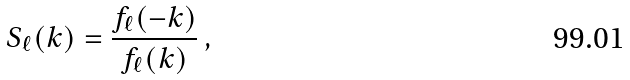<formula> <loc_0><loc_0><loc_500><loc_500>S _ { \ell } ( k ) = \frac { f _ { \ell } ( - k ) } { f _ { \ell } ( k ) } \, ,</formula> 